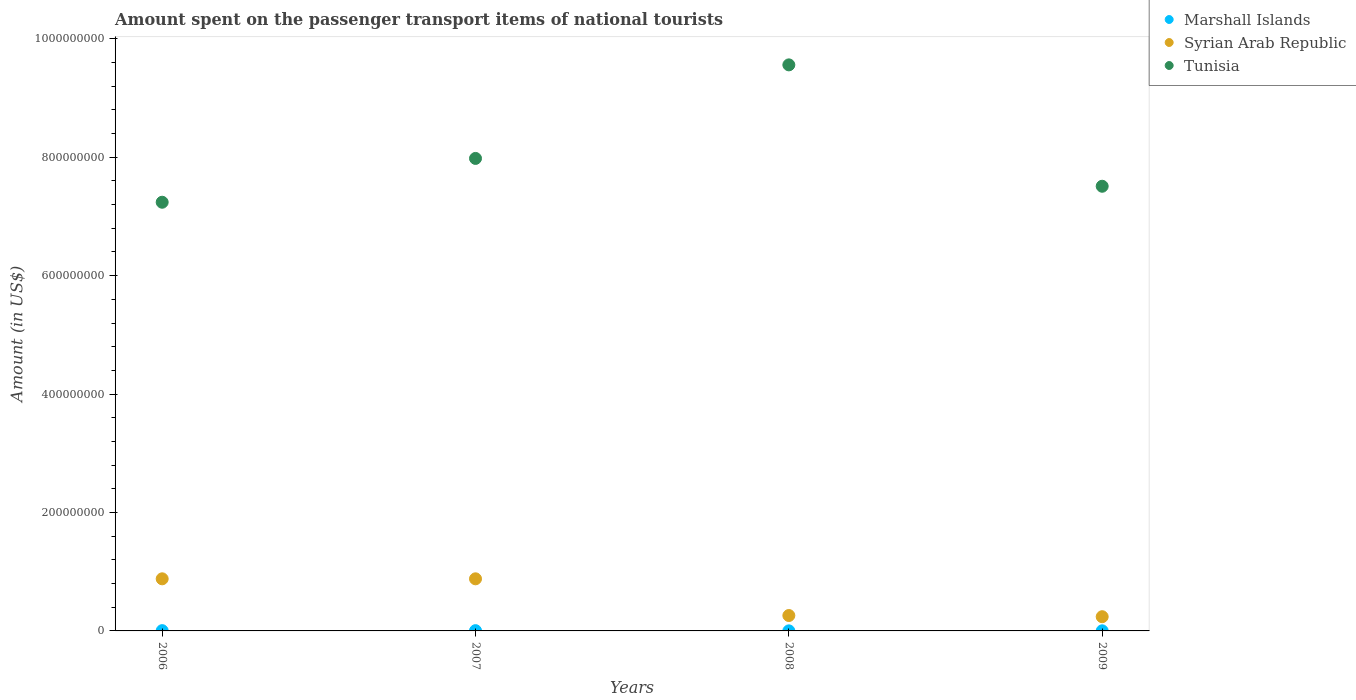Is the number of dotlines equal to the number of legend labels?
Provide a short and direct response. Yes. What is the amount spent on the passenger transport items of national tourists in Syrian Arab Republic in 2008?
Offer a terse response. 2.60e+07. Across all years, what is the maximum amount spent on the passenger transport items of national tourists in Syrian Arab Republic?
Your answer should be compact. 8.80e+07. Across all years, what is the minimum amount spent on the passenger transport items of national tourists in Syrian Arab Republic?
Give a very brief answer. 2.40e+07. In which year was the amount spent on the passenger transport items of national tourists in Tunisia maximum?
Keep it short and to the point. 2008. In which year was the amount spent on the passenger transport items of national tourists in Tunisia minimum?
Make the answer very short. 2006. What is the total amount spent on the passenger transport items of national tourists in Tunisia in the graph?
Provide a short and direct response. 3.23e+09. What is the difference between the amount spent on the passenger transport items of national tourists in Tunisia in 2006 and that in 2007?
Your answer should be very brief. -7.40e+07. What is the difference between the amount spent on the passenger transport items of national tourists in Tunisia in 2009 and the amount spent on the passenger transport items of national tourists in Syrian Arab Republic in 2008?
Keep it short and to the point. 7.25e+08. What is the average amount spent on the passenger transport items of national tourists in Tunisia per year?
Offer a very short reply. 8.07e+08. In the year 2006, what is the difference between the amount spent on the passenger transport items of national tourists in Syrian Arab Republic and amount spent on the passenger transport items of national tourists in Tunisia?
Your response must be concise. -6.36e+08. What is the ratio of the amount spent on the passenger transport items of national tourists in Marshall Islands in 2006 to that in 2007?
Make the answer very short. 1.04. Is the amount spent on the passenger transport items of national tourists in Tunisia in 2006 less than that in 2007?
Offer a terse response. Yes. Is the difference between the amount spent on the passenger transport items of national tourists in Syrian Arab Republic in 2007 and 2008 greater than the difference between the amount spent on the passenger transport items of national tourists in Tunisia in 2007 and 2008?
Your answer should be very brief. Yes. What is the difference between the highest and the lowest amount spent on the passenger transport items of national tourists in Tunisia?
Keep it short and to the point. 2.32e+08. Is the amount spent on the passenger transport items of national tourists in Syrian Arab Republic strictly less than the amount spent on the passenger transport items of national tourists in Tunisia over the years?
Your answer should be compact. Yes. How many dotlines are there?
Keep it short and to the point. 3. What is the difference between two consecutive major ticks on the Y-axis?
Keep it short and to the point. 2.00e+08. Are the values on the major ticks of Y-axis written in scientific E-notation?
Ensure brevity in your answer.  No. How many legend labels are there?
Make the answer very short. 3. What is the title of the graph?
Your response must be concise. Amount spent on the passenger transport items of national tourists. What is the label or title of the X-axis?
Offer a very short reply. Years. What is the Amount (in US$) of Marshall Islands in 2006?
Your answer should be compact. 4.70e+05. What is the Amount (in US$) of Syrian Arab Republic in 2006?
Offer a terse response. 8.80e+07. What is the Amount (in US$) in Tunisia in 2006?
Provide a succinct answer. 7.24e+08. What is the Amount (in US$) of Marshall Islands in 2007?
Offer a very short reply. 4.50e+05. What is the Amount (in US$) of Syrian Arab Republic in 2007?
Ensure brevity in your answer.  8.80e+07. What is the Amount (in US$) of Tunisia in 2007?
Give a very brief answer. 7.98e+08. What is the Amount (in US$) in Marshall Islands in 2008?
Provide a succinct answer. 1.10e+05. What is the Amount (in US$) in Syrian Arab Republic in 2008?
Give a very brief answer. 2.60e+07. What is the Amount (in US$) of Tunisia in 2008?
Offer a very short reply. 9.56e+08. What is the Amount (in US$) in Marshall Islands in 2009?
Your response must be concise. 1.80e+05. What is the Amount (in US$) in Syrian Arab Republic in 2009?
Give a very brief answer. 2.40e+07. What is the Amount (in US$) in Tunisia in 2009?
Your response must be concise. 7.51e+08. Across all years, what is the maximum Amount (in US$) of Marshall Islands?
Give a very brief answer. 4.70e+05. Across all years, what is the maximum Amount (in US$) in Syrian Arab Republic?
Offer a very short reply. 8.80e+07. Across all years, what is the maximum Amount (in US$) of Tunisia?
Make the answer very short. 9.56e+08. Across all years, what is the minimum Amount (in US$) of Marshall Islands?
Ensure brevity in your answer.  1.10e+05. Across all years, what is the minimum Amount (in US$) in Syrian Arab Republic?
Make the answer very short. 2.40e+07. Across all years, what is the minimum Amount (in US$) in Tunisia?
Provide a succinct answer. 7.24e+08. What is the total Amount (in US$) of Marshall Islands in the graph?
Provide a succinct answer. 1.21e+06. What is the total Amount (in US$) in Syrian Arab Republic in the graph?
Your answer should be compact. 2.26e+08. What is the total Amount (in US$) in Tunisia in the graph?
Your response must be concise. 3.23e+09. What is the difference between the Amount (in US$) of Syrian Arab Republic in 2006 and that in 2007?
Provide a succinct answer. 0. What is the difference between the Amount (in US$) of Tunisia in 2006 and that in 2007?
Give a very brief answer. -7.40e+07. What is the difference between the Amount (in US$) in Syrian Arab Republic in 2006 and that in 2008?
Give a very brief answer. 6.20e+07. What is the difference between the Amount (in US$) of Tunisia in 2006 and that in 2008?
Provide a short and direct response. -2.32e+08. What is the difference between the Amount (in US$) of Syrian Arab Republic in 2006 and that in 2009?
Your answer should be very brief. 6.40e+07. What is the difference between the Amount (in US$) of Tunisia in 2006 and that in 2009?
Your answer should be compact. -2.70e+07. What is the difference between the Amount (in US$) of Marshall Islands in 2007 and that in 2008?
Provide a short and direct response. 3.40e+05. What is the difference between the Amount (in US$) of Syrian Arab Republic in 2007 and that in 2008?
Make the answer very short. 6.20e+07. What is the difference between the Amount (in US$) of Tunisia in 2007 and that in 2008?
Offer a very short reply. -1.58e+08. What is the difference between the Amount (in US$) in Marshall Islands in 2007 and that in 2009?
Keep it short and to the point. 2.70e+05. What is the difference between the Amount (in US$) of Syrian Arab Republic in 2007 and that in 2009?
Offer a terse response. 6.40e+07. What is the difference between the Amount (in US$) of Tunisia in 2007 and that in 2009?
Offer a very short reply. 4.70e+07. What is the difference between the Amount (in US$) of Tunisia in 2008 and that in 2009?
Give a very brief answer. 2.05e+08. What is the difference between the Amount (in US$) of Marshall Islands in 2006 and the Amount (in US$) of Syrian Arab Republic in 2007?
Keep it short and to the point. -8.75e+07. What is the difference between the Amount (in US$) in Marshall Islands in 2006 and the Amount (in US$) in Tunisia in 2007?
Offer a very short reply. -7.98e+08. What is the difference between the Amount (in US$) in Syrian Arab Republic in 2006 and the Amount (in US$) in Tunisia in 2007?
Provide a short and direct response. -7.10e+08. What is the difference between the Amount (in US$) of Marshall Islands in 2006 and the Amount (in US$) of Syrian Arab Republic in 2008?
Keep it short and to the point. -2.55e+07. What is the difference between the Amount (in US$) of Marshall Islands in 2006 and the Amount (in US$) of Tunisia in 2008?
Make the answer very short. -9.56e+08. What is the difference between the Amount (in US$) in Syrian Arab Republic in 2006 and the Amount (in US$) in Tunisia in 2008?
Your response must be concise. -8.68e+08. What is the difference between the Amount (in US$) of Marshall Islands in 2006 and the Amount (in US$) of Syrian Arab Republic in 2009?
Offer a terse response. -2.35e+07. What is the difference between the Amount (in US$) of Marshall Islands in 2006 and the Amount (in US$) of Tunisia in 2009?
Keep it short and to the point. -7.51e+08. What is the difference between the Amount (in US$) of Syrian Arab Republic in 2006 and the Amount (in US$) of Tunisia in 2009?
Ensure brevity in your answer.  -6.63e+08. What is the difference between the Amount (in US$) of Marshall Islands in 2007 and the Amount (in US$) of Syrian Arab Republic in 2008?
Offer a very short reply. -2.56e+07. What is the difference between the Amount (in US$) of Marshall Islands in 2007 and the Amount (in US$) of Tunisia in 2008?
Offer a terse response. -9.56e+08. What is the difference between the Amount (in US$) in Syrian Arab Republic in 2007 and the Amount (in US$) in Tunisia in 2008?
Your answer should be very brief. -8.68e+08. What is the difference between the Amount (in US$) in Marshall Islands in 2007 and the Amount (in US$) in Syrian Arab Republic in 2009?
Provide a succinct answer. -2.36e+07. What is the difference between the Amount (in US$) of Marshall Islands in 2007 and the Amount (in US$) of Tunisia in 2009?
Make the answer very short. -7.51e+08. What is the difference between the Amount (in US$) in Syrian Arab Republic in 2007 and the Amount (in US$) in Tunisia in 2009?
Your answer should be very brief. -6.63e+08. What is the difference between the Amount (in US$) in Marshall Islands in 2008 and the Amount (in US$) in Syrian Arab Republic in 2009?
Your response must be concise. -2.39e+07. What is the difference between the Amount (in US$) of Marshall Islands in 2008 and the Amount (in US$) of Tunisia in 2009?
Ensure brevity in your answer.  -7.51e+08. What is the difference between the Amount (in US$) in Syrian Arab Republic in 2008 and the Amount (in US$) in Tunisia in 2009?
Ensure brevity in your answer.  -7.25e+08. What is the average Amount (in US$) in Marshall Islands per year?
Keep it short and to the point. 3.02e+05. What is the average Amount (in US$) of Syrian Arab Republic per year?
Your answer should be very brief. 5.65e+07. What is the average Amount (in US$) of Tunisia per year?
Your response must be concise. 8.07e+08. In the year 2006, what is the difference between the Amount (in US$) of Marshall Islands and Amount (in US$) of Syrian Arab Republic?
Provide a short and direct response. -8.75e+07. In the year 2006, what is the difference between the Amount (in US$) in Marshall Islands and Amount (in US$) in Tunisia?
Give a very brief answer. -7.24e+08. In the year 2006, what is the difference between the Amount (in US$) of Syrian Arab Republic and Amount (in US$) of Tunisia?
Provide a succinct answer. -6.36e+08. In the year 2007, what is the difference between the Amount (in US$) of Marshall Islands and Amount (in US$) of Syrian Arab Republic?
Your response must be concise. -8.76e+07. In the year 2007, what is the difference between the Amount (in US$) in Marshall Islands and Amount (in US$) in Tunisia?
Ensure brevity in your answer.  -7.98e+08. In the year 2007, what is the difference between the Amount (in US$) in Syrian Arab Republic and Amount (in US$) in Tunisia?
Your response must be concise. -7.10e+08. In the year 2008, what is the difference between the Amount (in US$) of Marshall Islands and Amount (in US$) of Syrian Arab Republic?
Provide a succinct answer. -2.59e+07. In the year 2008, what is the difference between the Amount (in US$) in Marshall Islands and Amount (in US$) in Tunisia?
Provide a succinct answer. -9.56e+08. In the year 2008, what is the difference between the Amount (in US$) of Syrian Arab Republic and Amount (in US$) of Tunisia?
Provide a short and direct response. -9.30e+08. In the year 2009, what is the difference between the Amount (in US$) of Marshall Islands and Amount (in US$) of Syrian Arab Republic?
Ensure brevity in your answer.  -2.38e+07. In the year 2009, what is the difference between the Amount (in US$) of Marshall Islands and Amount (in US$) of Tunisia?
Keep it short and to the point. -7.51e+08. In the year 2009, what is the difference between the Amount (in US$) in Syrian Arab Republic and Amount (in US$) in Tunisia?
Your response must be concise. -7.27e+08. What is the ratio of the Amount (in US$) of Marshall Islands in 2006 to that in 2007?
Offer a very short reply. 1.04. What is the ratio of the Amount (in US$) in Syrian Arab Republic in 2006 to that in 2007?
Keep it short and to the point. 1. What is the ratio of the Amount (in US$) of Tunisia in 2006 to that in 2007?
Offer a very short reply. 0.91. What is the ratio of the Amount (in US$) in Marshall Islands in 2006 to that in 2008?
Your response must be concise. 4.27. What is the ratio of the Amount (in US$) in Syrian Arab Republic in 2006 to that in 2008?
Make the answer very short. 3.38. What is the ratio of the Amount (in US$) of Tunisia in 2006 to that in 2008?
Provide a short and direct response. 0.76. What is the ratio of the Amount (in US$) in Marshall Islands in 2006 to that in 2009?
Keep it short and to the point. 2.61. What is the ratio of the Amount (in US$) in Syrian Arab Republic in 2006 to that in 2009?
Provide a short and direct response. 3.67. What is the ratio of the Amount (in US$) of Tunisia in 2006 to that in 2009?
Provide a short and direct response. 0.96. What is the ratio of the Amount (in US$) of Marshall Islands in 2007 to that in 2008?
Provide a succinct answer. 4.09. What is the ratio of the Amount (in US$) of Syrian Arab Republic in 2007 to that in 2008?
Your answer should be very brief. 3.38. What is the ratio of the Amount (in US$) in Tunisia in 2007 to that in 2008?
Give a very brief answer. 0.83. What is the ratio of the Amount (in US$) in Syrian Arab Republic in 2007 to that in 2009?
Provide a succinct answer. 3.67. What is the ratio of the Amount (in US$) in Tunisia in 2007 to that in 2009?
Give a very brief answer. 1.06. What is the ratio of the Amount (in US$) of Marshall Islands in 2008 to that in 2009?
Keep it short and to the point. 0.61. What is the ratio of the Amount (in US$) of Syrian Arab Republic in 2008 to that in 2009?
Ensure brevity in your answer.  1.08. What is the ratio of the Amount (in US$) of Tunisia in 2008 to that in 2009?
Offer a terse response. 1.27. What is the difference between the highest and the second highest Amount (in US$) in Marshall Islands?
Provide a succinct answer. 2.00e+04. What is the difference between the highest and the second highest Amount (in US$) in Syrian Arab Republic?
Give a very brief answer. 0. What is the difference between the highest and the second highest Amount (in US$) of Tunisia?
Your answer should be compact. 1.58e+08. What is the difference between the highest and the lowest Amount (in US$) of Syrian Arab Republic?
Ensure brevity in your answer.  6.40e+07. What is the difference between the highest and the lowest Amount (in US$) of Tunisia?
Your answer should be very brief. 2.32e+08. 